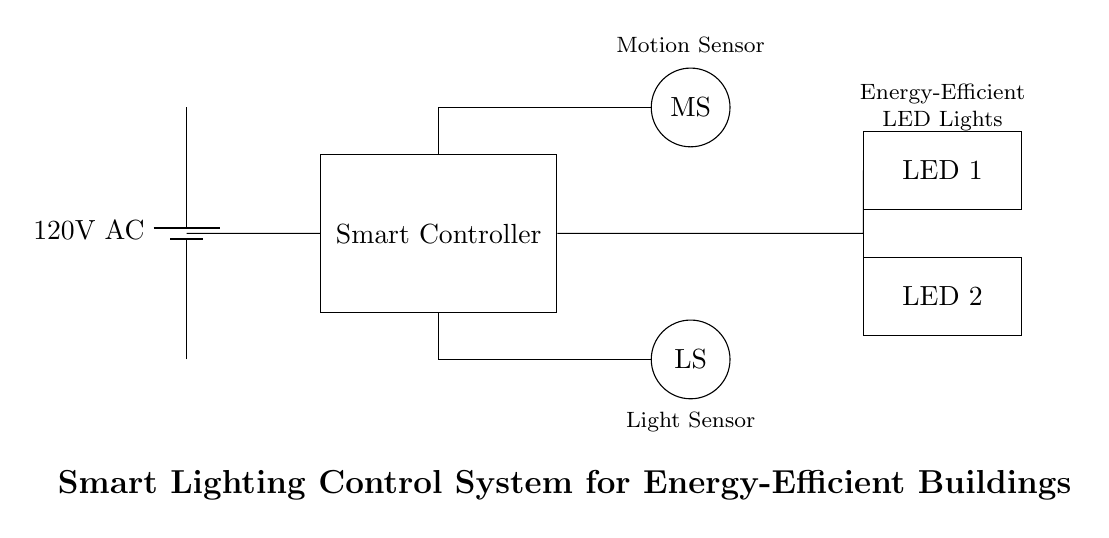What is the main power supply voltage? The circuit diagram shows a battery labeled as providing 120 volts AC, indicating the voltage supplied to the circuit.
Answer: 120 volts AC What components are used in the smart lighting control system? The circuit diagram includes a Smart Controller, Motion Sensor (labelled MS), Light Sensor (labelled LS), and two LED lights. These are the primary components visible in the diagram.
Answer: Smart Controller, Motion Sensor, Light Sensor, LED lights How many LED lights are present in the circuit? There are two LED lights indicated as LED 1 and LED 2 in the circuit diagram. The labels clearly state the presence of these two components.
Answer: 2 What is the purpose of the motion sensor in this circuit? The Motion Sensor detects movement, which is a crucial function for activating the LED lights when someone is present, thereby contributing to energy efficiency in the lighting system.
Answer: To detect movement What is the role of the light sensor in this circuit? The Light Sensor measures ambient light levels, allowing the Smart Controller to adjust the LED lighting according to the available natural light, thus optimizing energy usage.
Answer: To measure ambient light levels How does the Smart Controller interact with the sensors? The Smart Controller receives input from both the Motion Sensor and the Light Sensor to determine when to turn on or adjust the LED lights, acting based on the data received from these sensors.
Answer: It processes input from the sensors 